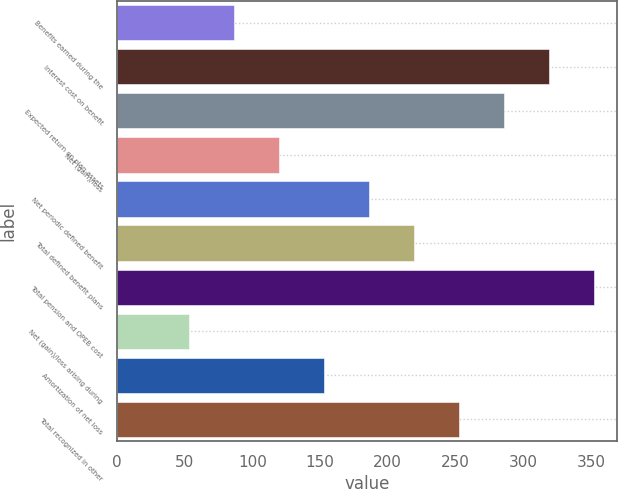Convert chart. <chart><loc_0><loc_0><loc_500><loc_500><bar_chart><fcel>Benefits earned during the<fcel>Interest cost on benefit<fcel>Expected return on plan assets<fcel>Net (gain)/loss<fcel>Net periodic defined benefit<fcel>Total defined benefit plans<fcel>Total pension and OPEB cost<fcel>Net (gain)/loss arising during<fcel>Amortization of net loss<fcel>Total recognized in other<nl><fcel>86.4<fcel>318.8<fcel>285.6<fcel>119.6<fcel>186<fcel>219.2<fcel>352<fcel>53.2<fcel>152.8<fcel>252.4<nl></chart> 